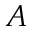Convert formula to latex. <formula><loc_0><loc_0><loc_500><loc_500>A</formula> 